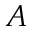Convert formula to latex. <formula><loc_0><loc_0><loc_500><loc_500>A</formula> 